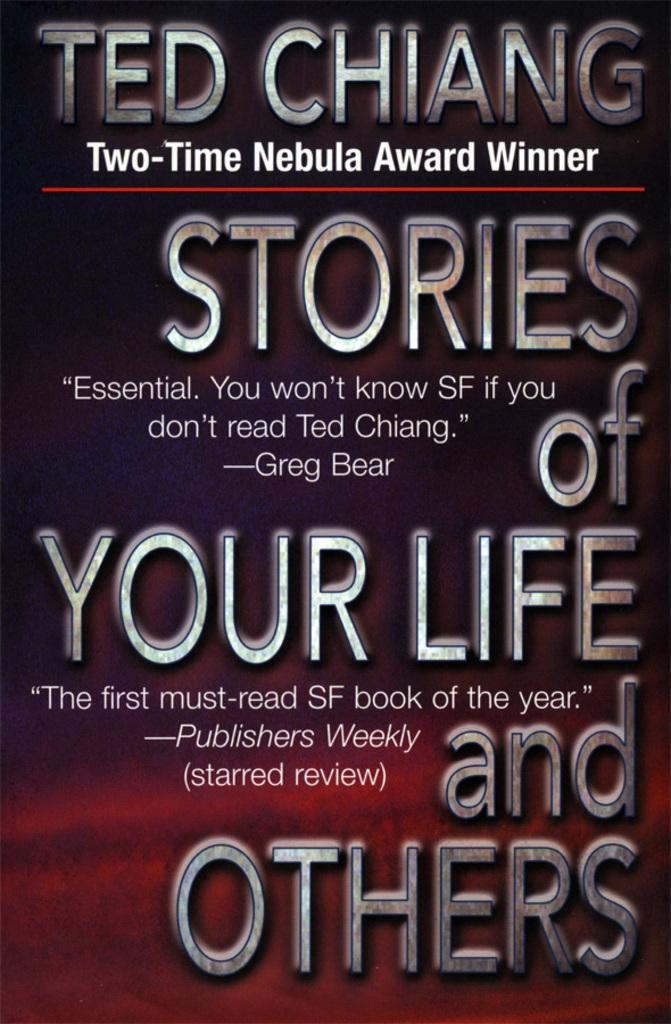<image>
Write a terse but informative summary of the picture. The author of this science fiction book has won the Nebula Award twice. 